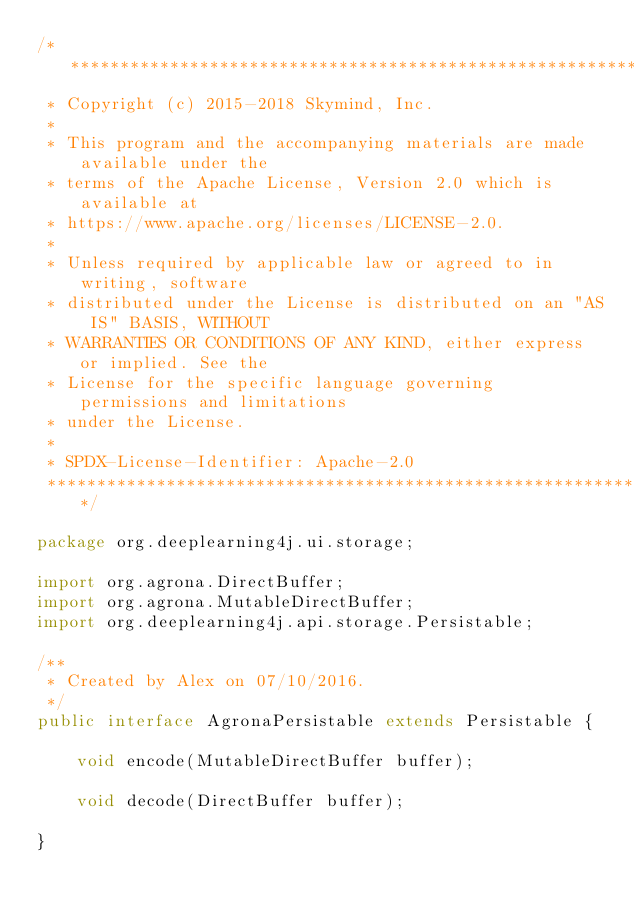Convert code to text. <code><loc_0><loc_0><loc_500><loc_500><_Java_>/*******************************************************************************
 * Copyright (c) 2015-2018 Skymind, Inc.
 *
 * This program and the accompanying materials are made available under the
 * terms of the Apache License, Version 2.0 which is available at
 * https://www.apache.org/licenses/LICENSE-2.0.
 *
 * Unless required by applicable law or agreed to in writing, software
 * distributed under the License is distributed on an "AS IS" BASIS, WITHOUT
 * WARRANTIES OR CONDITIONS OF ANY KIND, either express or implied. See the
 * License for the specific language governing permissions and limitations
 * under the License.
 *
 * SPDX-License-Identifier: Apache-2.0
 ******************************************************************************/

package org.deeplearning4j.ui.storage;

import org.agrona.DirectBuffer;
import org.agrona.MutableDirectBuffer;
import org.deeplearning4j.api.storage.Persistable;

/**
 * Created by Alex on 07/10/2016.
 */
public interface AgronaPersistable extends Persistable {

    void encode(MutableDirectBuffer buffer);

    void decode(DirectBuffer buffer);

}
</code> 